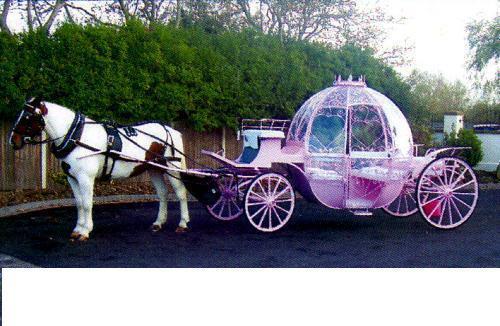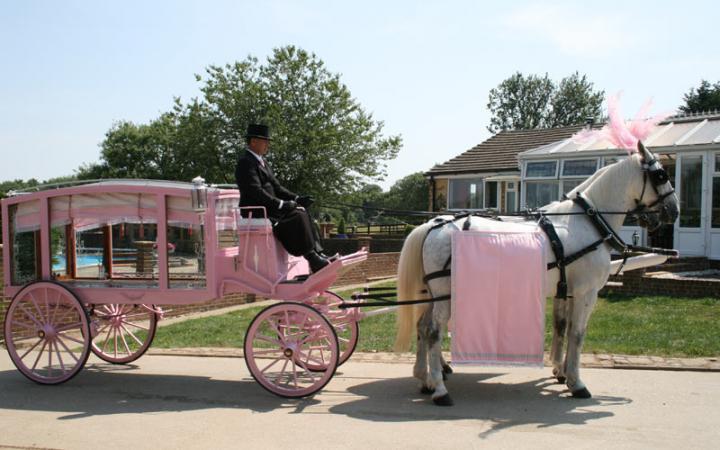The first image is the image on the left, the second image is the image on the right. Examine the images to the left and right. Is the description "At least two horses in the image on the left have pink head dresses." accurate? Answer yes or no. No. The first image is the image on the left, the second image is the image on the right. Considering the images on both sides, is "One of the carriages is pulled by a single horse." valid? Answer yes or no. Yes. 